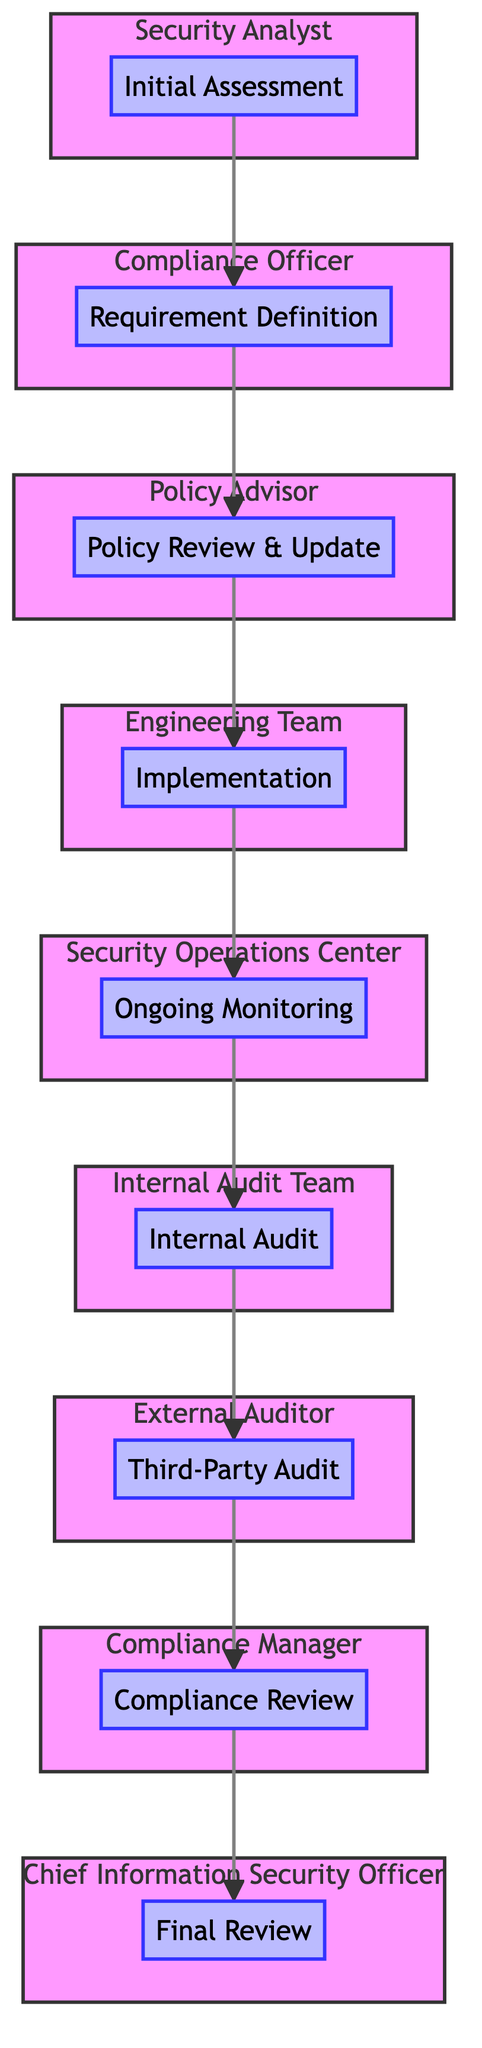What is the first step in the security audit trail? The first step in the security audit trail, as indicated in the diagram, is "Initial Assessment." This is identified at the bottom of the flow chart where the process begins.
Answer: Initial Assessment Who is responsible for the requirement definition? According to the diagram, the responsible party for requirement definition is the "Compliance Officer," which is specified next to the corresponding node.
Answer: Compliance Officer How many total steps are there in the flow chart? By counting the nodes in the diagram, there are a total of nine distinct steps in the flow chart, leading from "Initial Assessment" to "Final Review."
Answer: Nine What action is taken after the implementation stage? The diagram shows that after the implementation, the next action is "Ongoing Monitoring," which follows directly in the flow sequence.
Answer: Ongoing Monitoring What party conducts the internal audit? The diagram specifies that the "Internal Audit Team" is responsible for conducting the internal audit, positioned in the flow after "Ongoing Monitoring."
Answer: Internal Audit Team Which element precedes the final review? The diagram indicates that the step directly preceding the "Final Review" is the "Compliance Review," found immediately before it in the upward flow.
Answer: Compliance Review What is the role of the policy advisor in the audit trail? The policy advisor's role, as illustrated in the diagram, is to "Review and update security policies to align with defined requirements," which is part of the sequential process.
Answer: Review and update security policies How many roles are involved in this security audit trail process? There are eight distinct responsible parties mentioned in the diagram, illustrating each step's assigned roles throughout the audit process.
Answer: Eight What describes the link between ongoing monitoring and internal audit? In the flowchart, "Ongoing Monitoring" flows directly into "Internal Audit," indicating that the monitoring process feeds into the auditing stage as part of the compliance checks.
Answer: Ongoing Monitoring to Internal Audit 